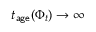Convert formula to latex. <formula><loc_0><loc_0><loc_500><loc_500>t _ { a g e } ( \Phi _ { t } ) \to \infty</formula> 